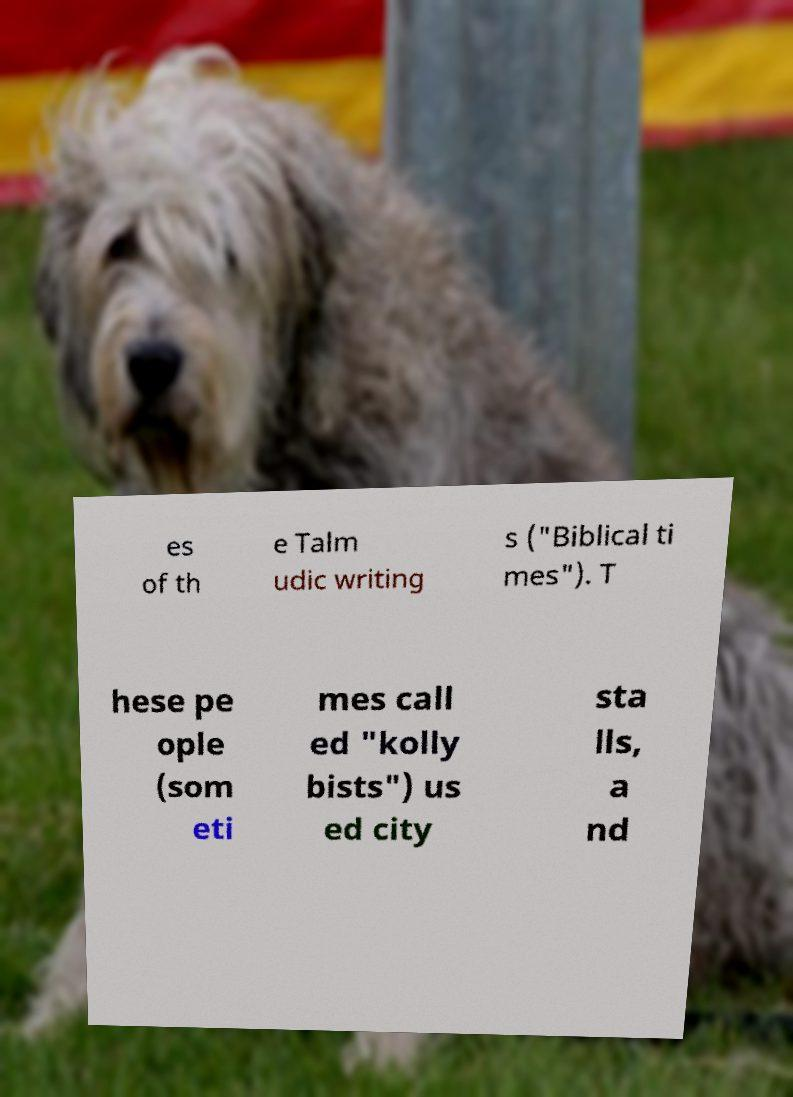For documentation purposes, I need the text within this image transcribed. Could you provide that? es of th e Talm udic writing s ("Biblical ti mes"). T hese pe ople (som eti mes call ed "kolly bists") us ed city sta lls, a nd 